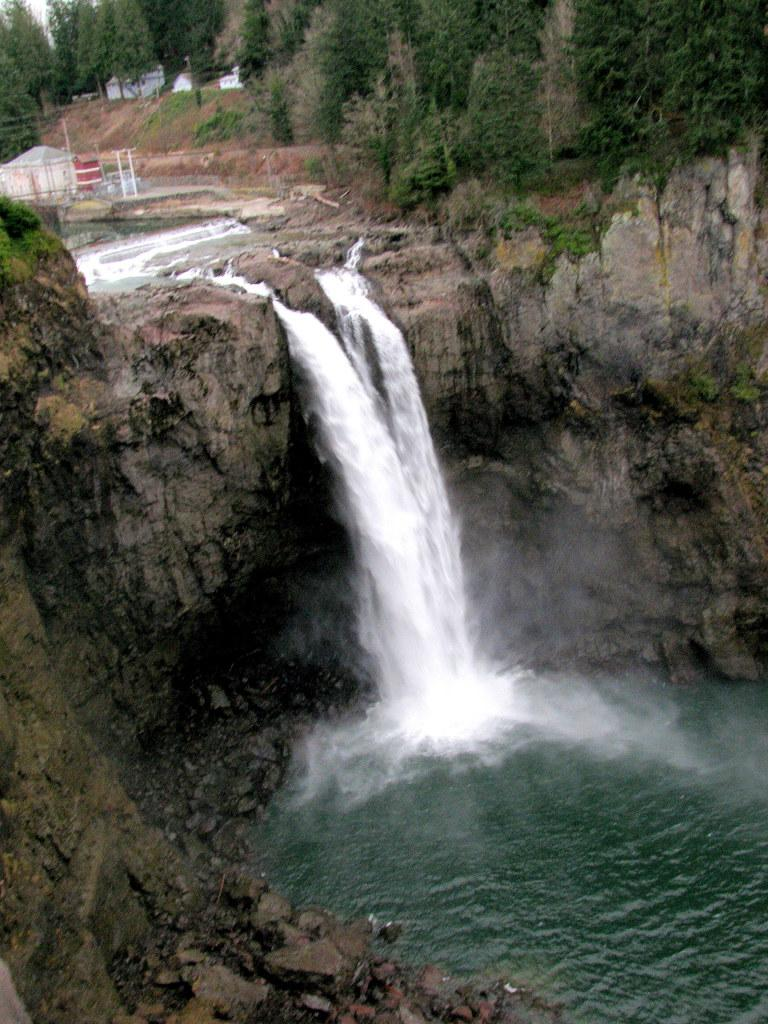What natural feature is the main subject of the image? There is a waterfall in the image. What other elements are present in the image? There are rocks and trees in the image. What can be seen in the background of the image? There are houses in the background of the image. How many eggs are being carried by the goose in the image? There is no goose or eggs present in the image. What angle is the waterfall falling at in the image? The angle at which the waterfall is falling cannot be determined from the image alone, as it is a two-dimensional representation. 